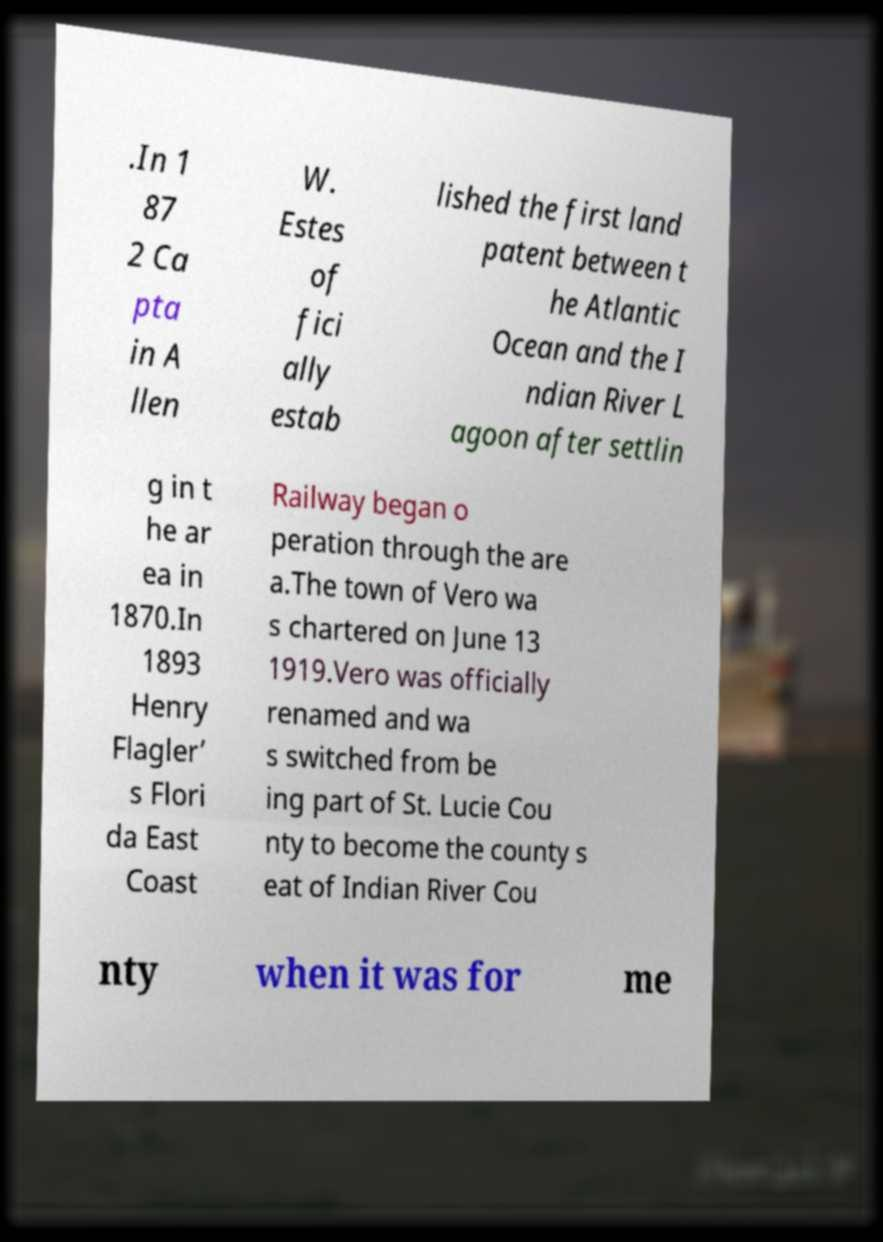I need the written content from this picture converted into text. Can you do that? .In 1 87 2 Ca pta in A llen W. Estes of fici ally estab lished the first land patent between t he Atlantic Ocean and the I ndian River L agoon after settlin g in t he ar ea in 1870.In 1893 Henry Flagler’ s Flori da East Coast Railway began o peration through the are a.The town of Vero wa s chartered on June 13 1919.Vero was officially renamed and wa s switched from be ing part of St. Lucie Cou nty to become the county s eat of Indian River Cou nty when it was for me 